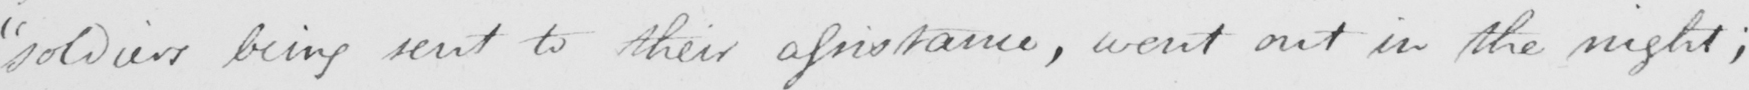Can you tell me what this handwritten text says? " soldiers being sent to their assistance , went out in the night ; 